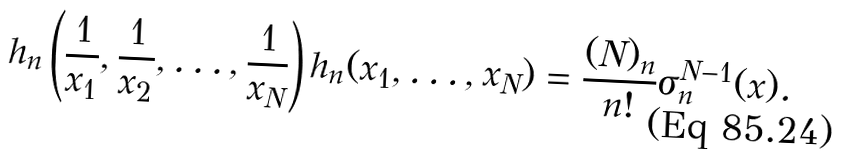<formula> <loc_0><loc_0><loc_500><loc_500>h _ { n } \left ( \frac { 1 } { x _ { 1 } } , \frac { 1 } { x _ { 2 } } , \dots , \frac { 1 } { x _ { N } } \right ) h _ { n } ( x _ { 1 } , \dots , x _ { N } ) = \frac { ( N ) _ { n } } { n ! } \sigma _ { n } ^ { N - 1 } ( x ) .</formula> 